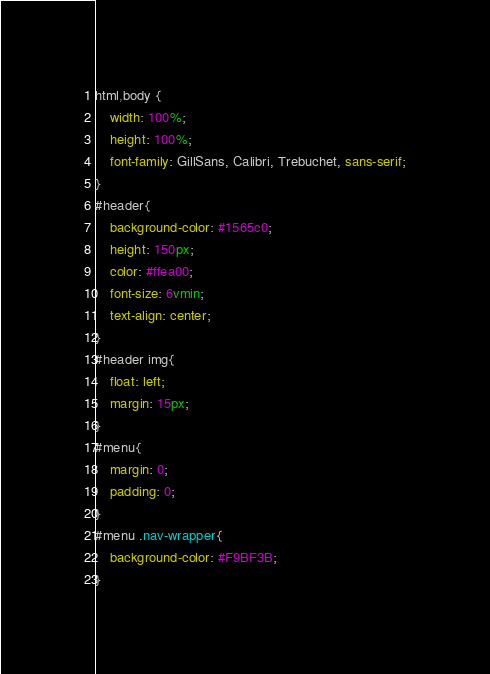Convert code to text. <code><loc_0><loc_0><loc_500><loc_500><_CSS_>html,body {
	width: 100%;
	height: 100%;
	font-family: GillSans, Calibri, Trebuchet, sans-serif;
}
#header{
	background-color: #1565c0;
	height: 150px;
	color: #ffea00;
	font-size: 6vmin;
	text-align: center;
}
#header img{
	float: left;
	margin: 15px;
}
#menu{
	margin: 0;
	padding: 0;
}
#menu .nav-wrapper{
	background-color: #F9BF3B;
}</code> 